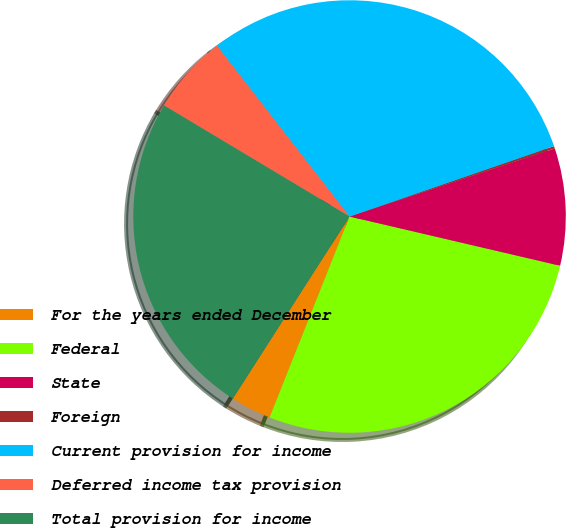Convert chart to OTSL. <chart><loc_0><loc_0><loc_500><loc_500><pie_chart><fcel>For the years ended December<fcel>Federal<fcel>State<fcel>Foreign<fcel>Current provision for income<fcel>Deferred income tax provision<fcel>Total provision for income<nl><fcel>3.04%<fcel>27.37%<fcel>8.75%<fcel>0.18%<fcel>30.23%<fcel>5.9%<fcel>24.52%<nl></chart> 